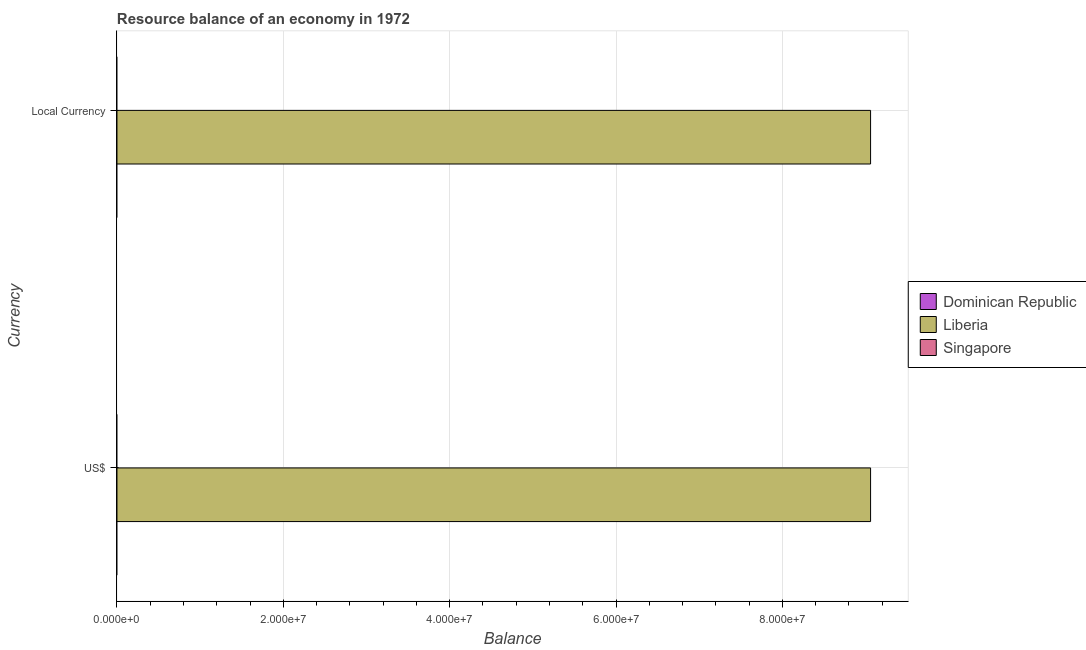Are the number of bars per tick equal to the number of legend labels?
Provide a short and direct response. No. Are the number of bars on each tick of the Y-axis equal?
Your response must be concise. Yes. How many bars are there on the 1st tick from the bottom?
Your answer should be compact. 1. What is the label of the 2nd group of bars from the top?
Your response must be concise. US$. What is the resource balance in constant us$ in Dominican Republic?
Provide a succinct answer. 0. Across all countries, what is the maximum resource balance in constant us$?
Your answer should be compact. 9.06e+07. In which country was the resource balance in constant us$ maximum?
Offer a terse response. Liberia. What is the total resource balance in constant us$ in the graph?
Ensure brevity in your answer.  9.06e+07. What is the difference between the resource balance in us$ in Singapore and the resource balance in constant us$ in Liberia?
Offer a very short reply. -9.06e+07. What is the average resource balance in us$ per country?
Make the answer very short. 3.02e+07. What is the difference between the resource balance in constant us$ and resource balance in us$ in Liberia?
Your answer should be compact. 0. In how many countries, is the resource balance in us$ greater than the average resource balance in us$ taken over all countries?
Offer a terse response. 1. How many bars are there?
Make the answer very short. 2. How many countries are there in the graph?
Offer a very short reply. 3. Where does the legend appear in the graph?
Ensure brevity in your answer.  Center right. How many legend labels are there?
Provide a short and direct response. 3. What is the title of the graph?
Ensure brevity in your answer.  Resource balance of an economy in 1972. What is the label or title of the X-axis?
Your answer should be compact. Balance. What is the label or title of the Y-axis?
Your answer should be very brief. Currency. What is the Balance of Dominican Republic in US$?
Provide a short and direct response. 0. What is the Balance of Liberia in US$?
Give a very brief answer. 9.06e+07. What is the Balance of Singapore in US$?
Provide a short and direct response. 0. What is the Balance of Liberia in Local Currency?
Offer a terse response. 9.06e+07. What is the Balance of Singapore in Local Currency?
Provide a short and direct response. 0. Across all Currency, what is the maximum Balance of Liberia?
Provide a succinct answer. 9.06e+07. Across all Currency, what is the minimum Balance in Liberia?
Your answer should be compact. 9.06e+07. What is the total Balance in Liberia in the graph?
Your response must be concise. 1.81e+08. What is the average Balance in Dominican Republic per Currency?
Keep it short and to the point. 0. What is the average Balance in Liberia per Currency?
Offer a very short reply. 9.06e+07. What is the difference between the highest and the second highest Balance of Liberia?
Your answer should be very brief. 0. What is the difference between the highest and the lowest Balance in Liberia?
Offer a terse response. 0. 